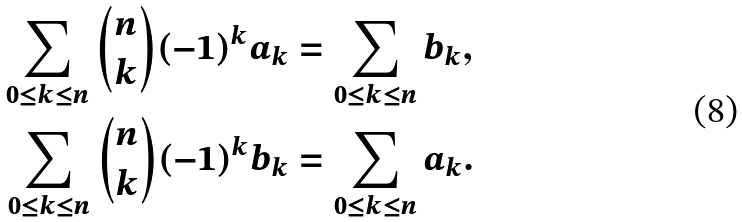Convert formula to latex. <formula><loc_0><loc_0><loc_500><loc_500>\sum _ { 0 \leq k \leq n } \binom { n } { k } ( - 1 ) ^ { k } a _ { k } & = \sum _ { 0 \leq k \leq n } b _ { k } , \\ \sum _ { 0 \leq k \leq n } \binom { n } { k } ( - 1 ) ^ { k } b _ { k } & = \sum _ { 0 \leq k \leq n } a _ { k } .</formula> 